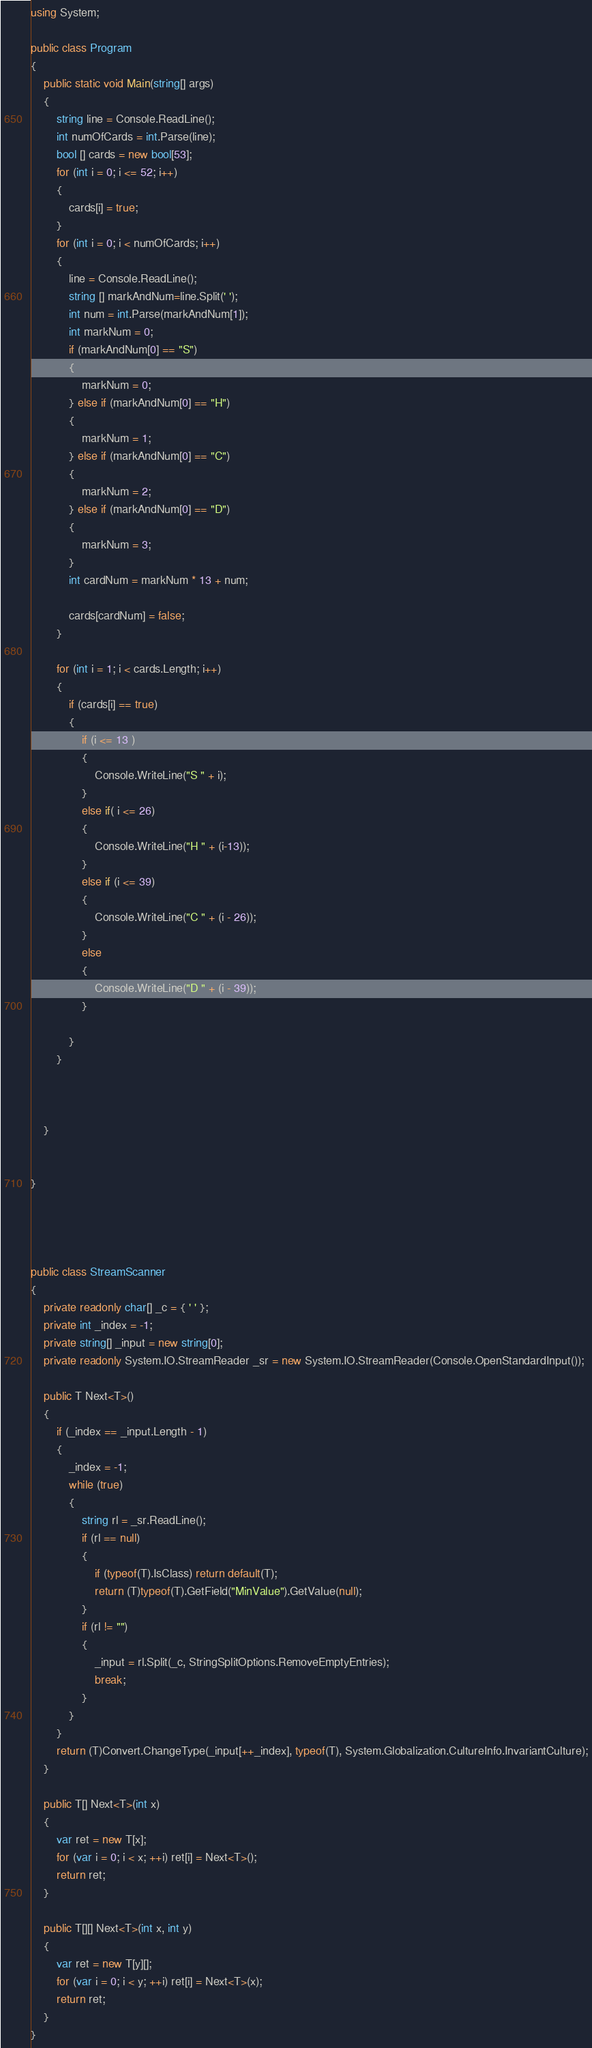Convert code to text. <code><loc_0><loc_0><loc_500><loc_500><_C#_>using System;

public class Program
{
	public static void Main(string[] args)
	{
		string line = Console.ReadLine();
		int numOfCards = int.Parse(line);
		bool [] cards = new bool[53];
		for (int i = 0; i <= 52; i++)
		{
			cards[i] = true;
		}
		for (int i = 0; i < numOfCards; i++)
		{
			line = Console.ReadLine();
			string [] markAndNum=line.Split(' ');
			int num = int.Parse(markAndNum[1]);
			int markNum = 0;
			if (markAndNum[0] == "S")
			{
				markNum = 0;
			} else if (markAndNum[0] == "H")
			{
				markNum = 1;
			} else if (markAndNum[0] == "C")
			{
				markNum = 2;
			} else if (markAndNum[0] == "D")
			{
				markNum = 3;
			}
			int cardNum = markNum * 13 + num;

			cards[cardNum] = false;
		}

		for (int i = 1; i < cards.Length; i++)
		{
			if (cards[i] == true)
			{
				if (i <= 13 )
				{
					Console.WriteLine("S " + i);
				}
				else if( i <= 26)
				{
					Console.WriteLine("H " + (i-13));
				}
				else if (i <= 39)
				{
					Console.WriteLine("C " + (i - 26));
				}
				else 
				{
					Console.WriteLine("D " + (i - 39));
				}
					
			}
		}


		
	}


}




public class StreamScanner
{
	private readonly char[] _c = { ' ' };
	private int _index = -1;
	private string[] _input = new string[0];
	private readonly System.IO.StreamReader _sr = new System.IO.StreamReader(Console.OpenStandardInput());

	public T Next<T>()
	{
		if (_index == _input.Length - 1)
		{
			_index = -1;
			while (true)
			{
				string rl = _sr.ReadLine();
				if (rl == null)
				{
					if (typeof(T).IsClass) return default(T);
					return (T)typeof(T).GetField("MinValue").GetValue(null);
				}
				if (rl != "")
				{
					_input = rl.Split(_c, StringSplitOptions.RemoveEmptyEntries);
					break;
				}
			}
		}
		return (T)Convert.ChangeType(_input[++_index], typeof(T), System.Globalization.CultureInfo.InvariantCulture);
	}

	public T[] Next<T>(int x)
	{
		var ret = new T[x];
		for (var i = 0; i < x; ++i) ret[i] = Next<T>();
		return ret;
	}

	public T[][] Next<T>(int x, int y)
	{
		var ret = new T[y][];
		for (var i = 0; i < y; ++i) ret[i] = Next<T>(x);
		return ret;
	}
}</code> 